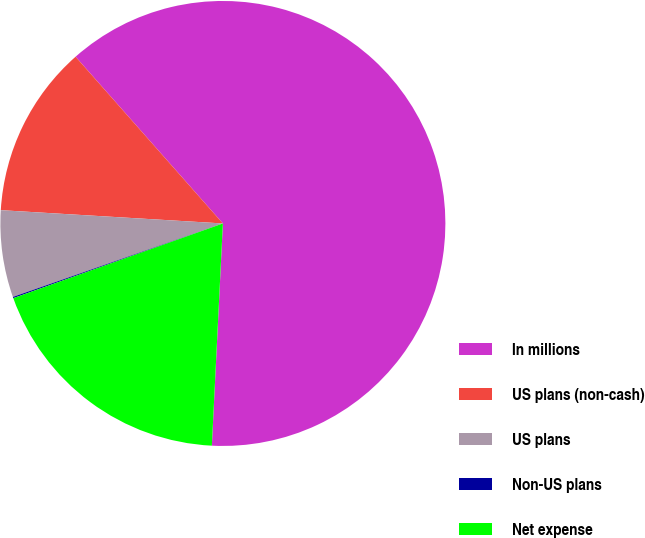Convert chart. <chart><loc_0><loc_0><loc_500><loc_500><pie_chart><fcel>In millions<fcel>US plans (non-cash)<fcel>US plans<fcel>Non-US plans<fcel>Net expense<nl><fcel>62.3%<fcel>12.53%<fcel>6.31%<fcel>0.09%<fcel>18.76%<nl></chart> 